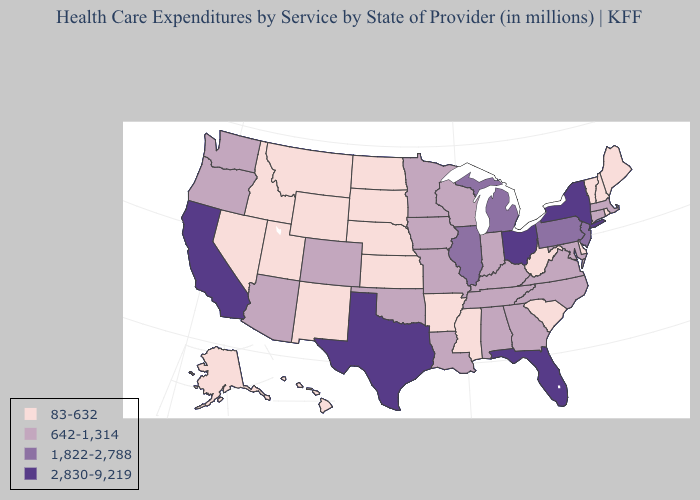Which states have the highest value in the USA?
Write a very short answer. California, Florida, New York, Ohio, Texas. Name the states that have a value in the range 642-1,314?
Answer briefly. Alabama, Arizona, Colorado, Connecticut, Georgia, Indiana, Iowa, Kentucky, Louisiana, Maryland, Massachusetts, Minnesota, Missouri, North Carolina, Oklahoma, Oregon, Tennessee, Virginia, Washington, Wisconsin. Does Arizona have the lowest value in the West?
Quick response, please. No. Does Arizona have the same value as Washington?
Keep it brief. Yes. What is the lowest value in states that border Wisconsin?
Write a very short answer. 642-1,314. Name the states that have a value in the range 1,822-2,788?
Answer briefly. Illinois, Michigan, New Jersey, Pennsylvania. What is the highest value in the USA?
Answer briefly. 2,830-9,219. What is the highest value in the USA?
Be succinct. 2,830-9,219. Which states have the lowest value in the Northeast?
Concise answer only. Maine, New Hampshire, Rhode Island, Vermont. Name the states that have a value in the range 1,822-2,788?
Concise answer only. Illinois, Michigan, New Jersey, Pennsylvania. Does Rhode Island have the lowest value in the USA?
Give a very brief answer. Yes. What is the highest value in the Northeast ?
Concise answer only. 2,830-9,219. Does Florida have the highest value in the South?
Concise answer only. Yes. What is the value of Pennsylvania?
Answer briefly. 1,822-2,788. 